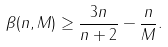Convert formula to latex. <formula><loc_0><loc_0><loc_500><loc_500>\beta ( n , M ) \geq \frac { 3 n } { n + 2 } - \frac { n } { M } .</formula> 